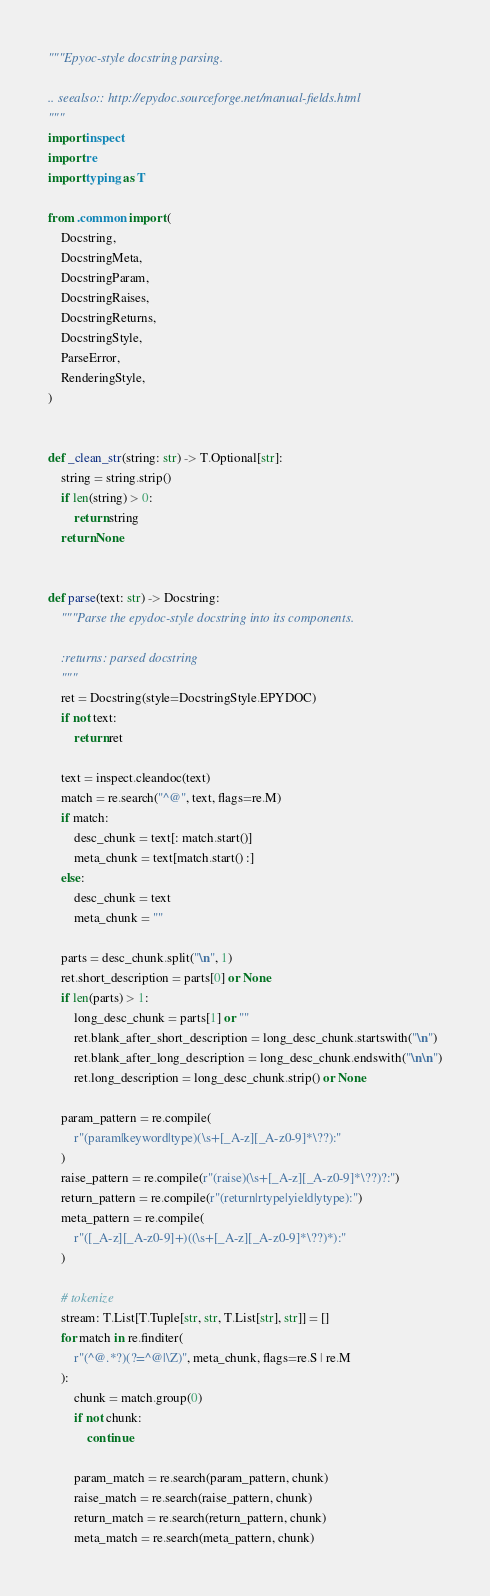<code> <loc_0><loc_0><loc_500><loc_500><_Python_>"""Epyoc-style docstring parsing.

.. seealso:: http://epydoc.sourceforge.net/manual-fields.html
"""
import inspect
import re
import typing as T

from .common import (
    Docstring,
    DocstringMeta,
    DocstringParam,
    DocstringRaises,
    DocstringReturns,
    DocstringStyle,
    ParseError,
    RenderingStyle,
)


def _clean_str(string: str) -> T.Optional[str]:
    string = string.strip()
    if len(string) > 0:
        return string
    return None


def parse(text: str) -> Docstring:
    """Parse the epydoc-style docstring into its components.

    :returns: parsed docstring
    """
    ret = Docstring(style=DocstringStyle.EPYDOC)
    if not text:
        return ret

    text = inspect.cleandoc(text)
    match = re.search("^@", text, flags=re.M)
    if match:
        desc_chunk = text[: match.start()]
        meta_chunk = text[match.start() :]
    else:
        desc_chunk = text
        meta_chunk = ""

    parts = desc_chunk.split("\n", 1)
    ret.short_description = parts[0] or None
    if len(parts) > 1:
        long_desc_chunk = parts[1] or ""
        ret.blank_after_short_description = long_desc_chunk.startswith("\n")
        ret.blank_after_long_description = long_desc_chunk.endswith("\n\n")
        ret.long_description = long_desc_chunk.strip() or None

    param_pattern = re.compile(
        r"(param|keyword|type)(\s+[_A-z][_A-z0-9]*\??):"
    )
    raise_pattern = re.compile(r"(raise)(\s+[_A-z][_A-z0-9]*\??)?:")
    return_pattern = re.compile(r"(return|rtype|yield|ytype):")
    meta_pattern = re.compile(
        r"([_A-z][_A-z0-9]+)((\s+[_A-z][_A-z0-9]*\??)*):"
    )

    # tokenize
    stream: T.List[T.Tuple[str, str, T.List[str], str]] = []
    for match in re.finditer(
        r"(^@.*?)(?=^@|\Z)", meta_chunk, flags=re.S | re.M
    ):
        chunk = match.group(0)
        if not chunk:
            continue

        param_match = re.search(param_pattern, chunk)
        raise_match = re.search(raise_pattern, chunk)
        return_match = re.search(return_pattern, chunk)
        meta_match = re.search(meta_pattern, chunk)
</code> 